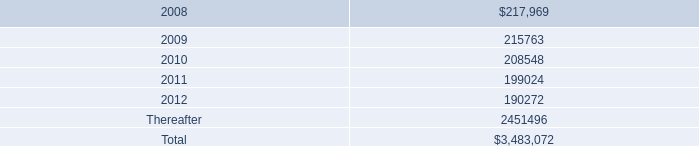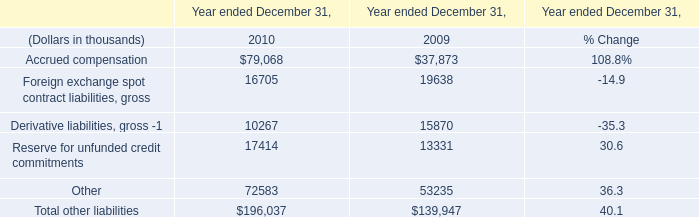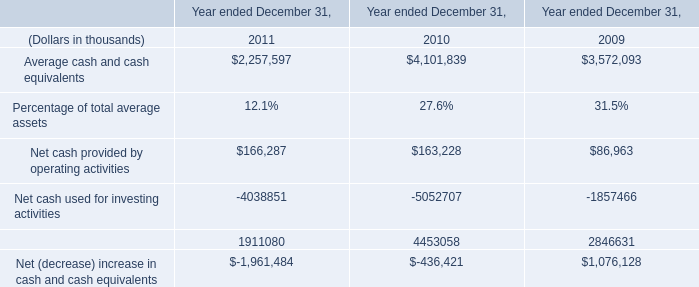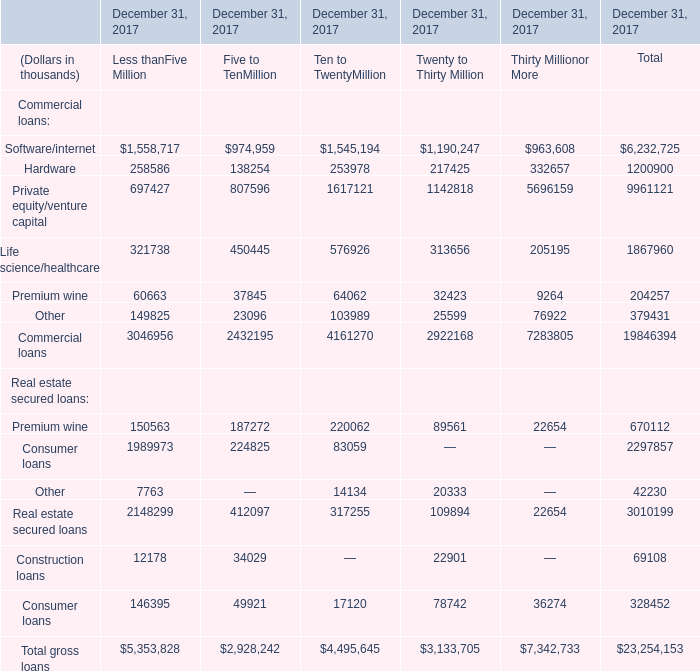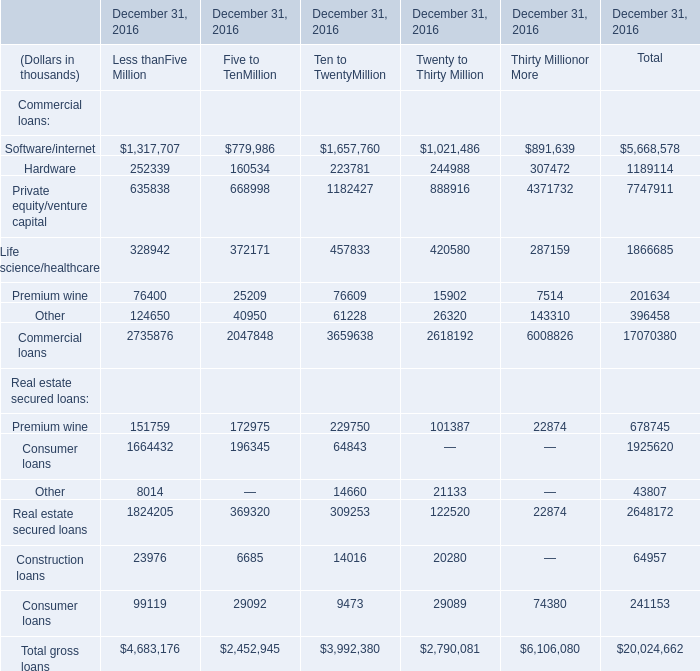What was the average of the Commercial loans in the years where Private equity/venture capital is positive? (in thousand) 
Computations: (17070380 / 1)
Answer: 17070380.0. 